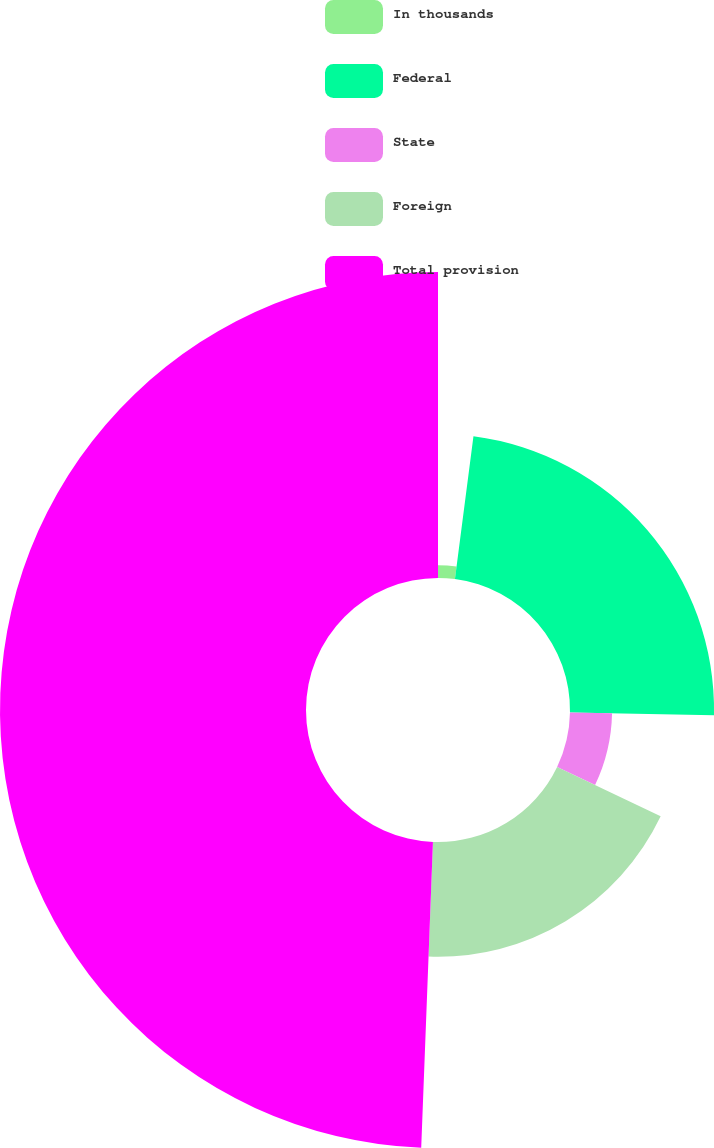<chart> <loc_0><loc_0><loc_500><loc_500><pie_chart><fcel>In thousands<fcel>Federal<fcel>State<fcel>Foreign<fcel>Total provision<nl><fcel>2.05%<fcel>23.25%<fcel>6.79%<fcel>18.52%<fcel>49.39%<nl></chart> 